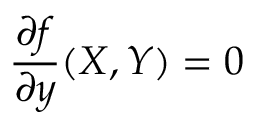<formula> <loc_0><loc_0><loc_500><loc_500>{ \frac { \partial f } { \partial y } } ( X , Y ) = 0</formula> 